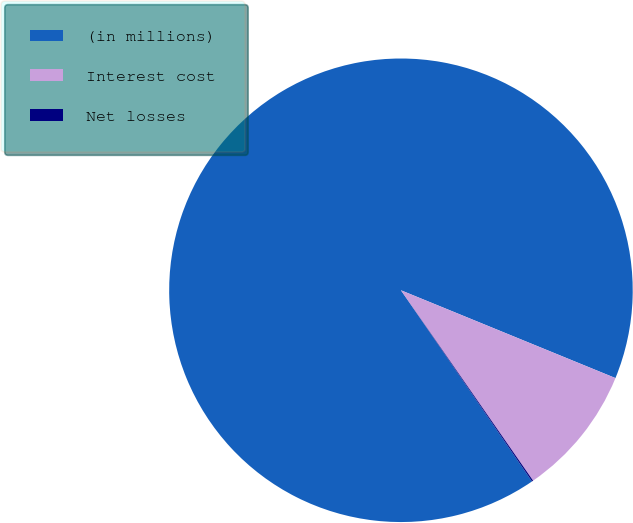Convert chart to OTSL. <chart><loc_0><loc_0><loc_500><loc_500><pie_chart><fcel>(in millions)<fcel>Interest cost<fcel>Net losses<nl><fcel>90.75%<fcel>9.16%<fcel>0.09%<nl></chart> 